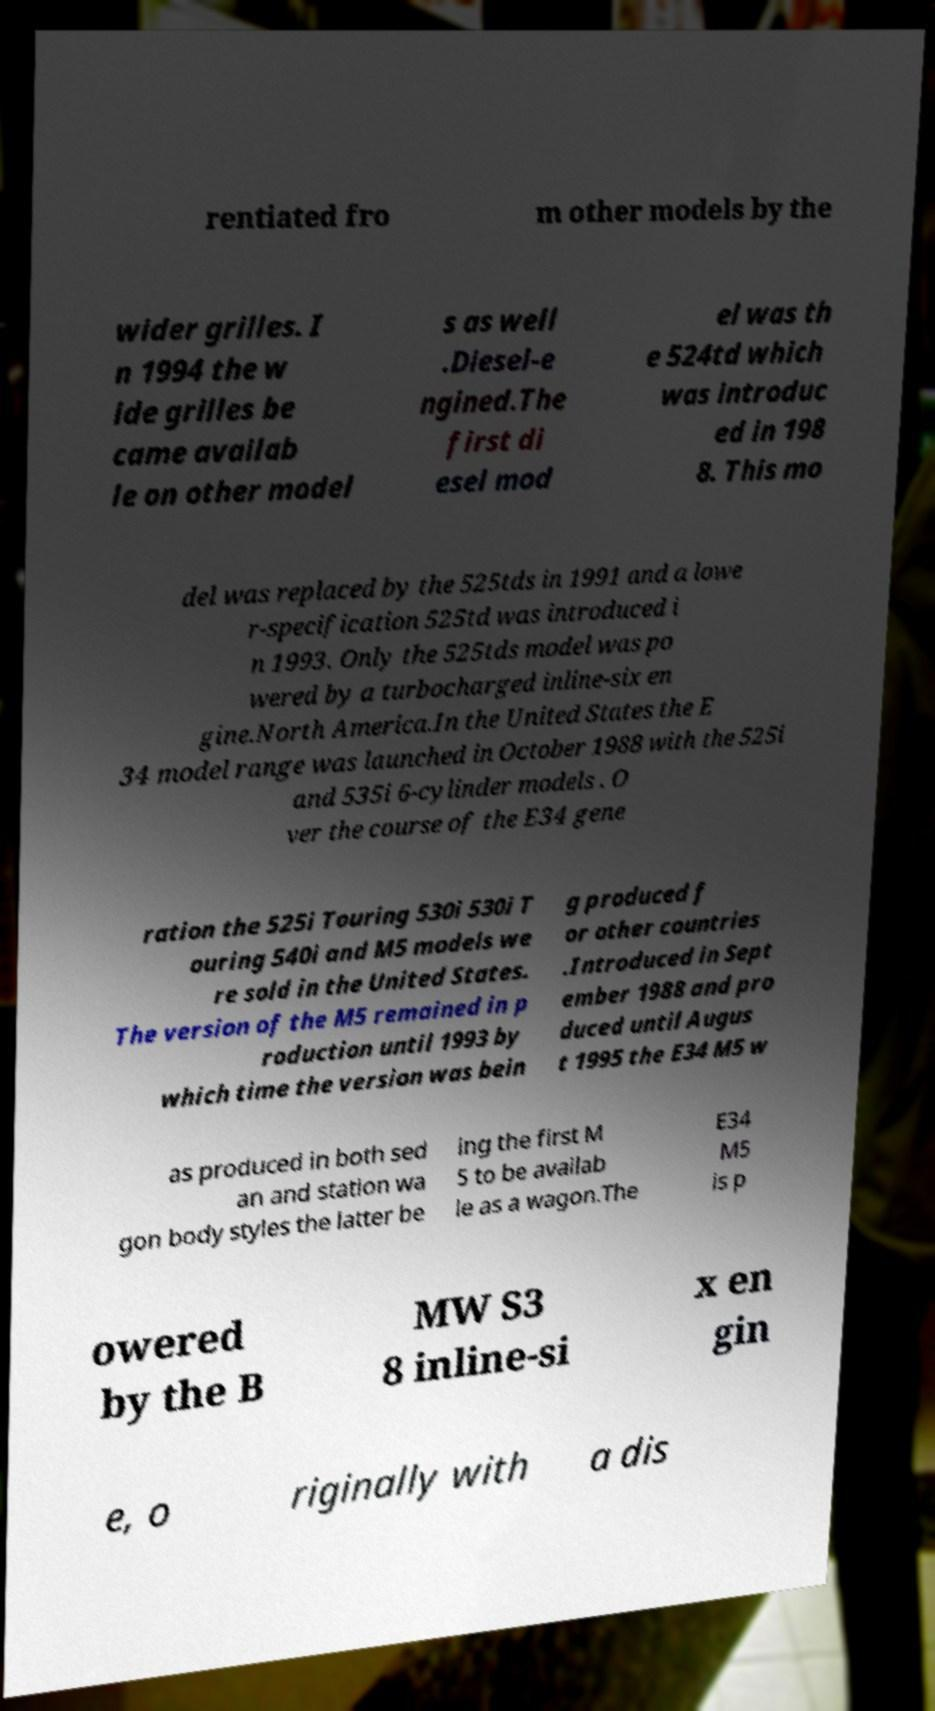Please identify and transcribe the text found in this image. rentiated fro m other models by the wider grilles. I n 1994 the w ide grilles be came availab le on other model s as well .Diesel-e ngined.The first di esel mod el was th e 524td which was introduc ed in 198 8. This mo del was replaced by the 525tds in 1991 and a lowe r-specification 525td was introduced i n 1993. Only the 525tds model was po wered by a turbocharged inline-six en gine.North America.In the United States the E 34 model range was launched in October 1988 with the 525i and 535i 6-cylinder models . O ver the course of the E34 gene ration the 525i Touring 530i 530i T ouring 540i and M5 models we re sold in the United States. The version of the M5 remained in p roduction until 1993 by which time the version was bein g produced f or other countries .Introduced in Sept ember 1988 and pro duced until Augus t 1995 the E34 M5 w as produced in both sed an and station wa gon body styles the latter be ing the first M 5 to be availab le as a wagon.The E34 M5 is p owered by the B MW S3 8 inline-si x en gin e, o riginally with a dis 